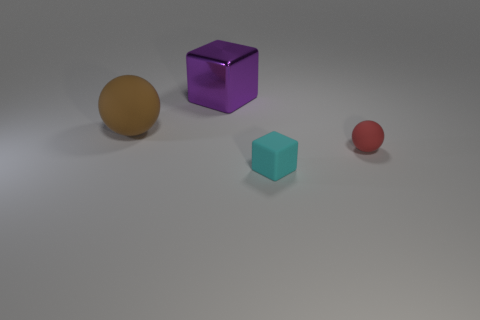Add 2 big rubber spheres. How many objects exist? 6 Subtract all large shiny cubes. Subtract all small balls. How many objects are left? 2 Add 2 tiny things. How many tiny things are left? 4 Add 1 tiny rubber cubes. How many tiny rubber cubes exist? 2 Subtract 0 purple cylinders. How many objects are left? 4 